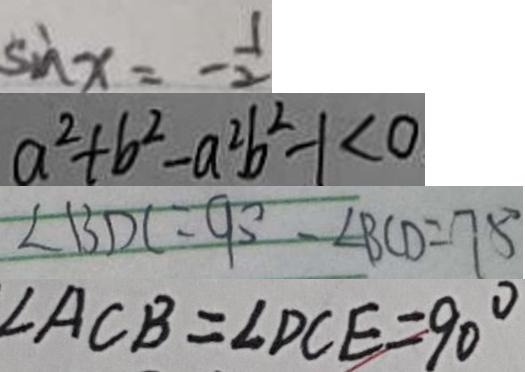Convert formula to latex. <formula><loc_0><loc_0><loc_500><loc_500>\sin x = - \frac { 1 } { 2 } 
 a ^ { 2 } + b ^ { 2 } - a ^ { 2 } b ^ { 2 } - 1 < 0 
 \angle B D C = 9 0 ^ { \circ } - \angle B C D = 7 5 ^ { \circ } 
 \angle A C B = \angle D C E = 9 0 ^ { \circ }</formula> 